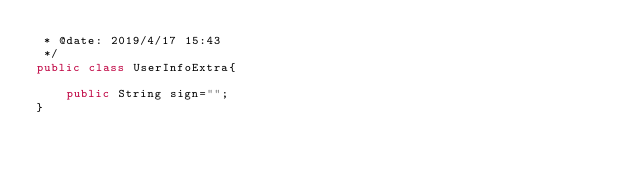Convert code to text. <code><loc_0><loc_0><loc_500><loc_500><_Java_> * @date: 2019/4/17 15:43
 */
public class UserInfoExtra{

    public String sign="";
}
</code> 